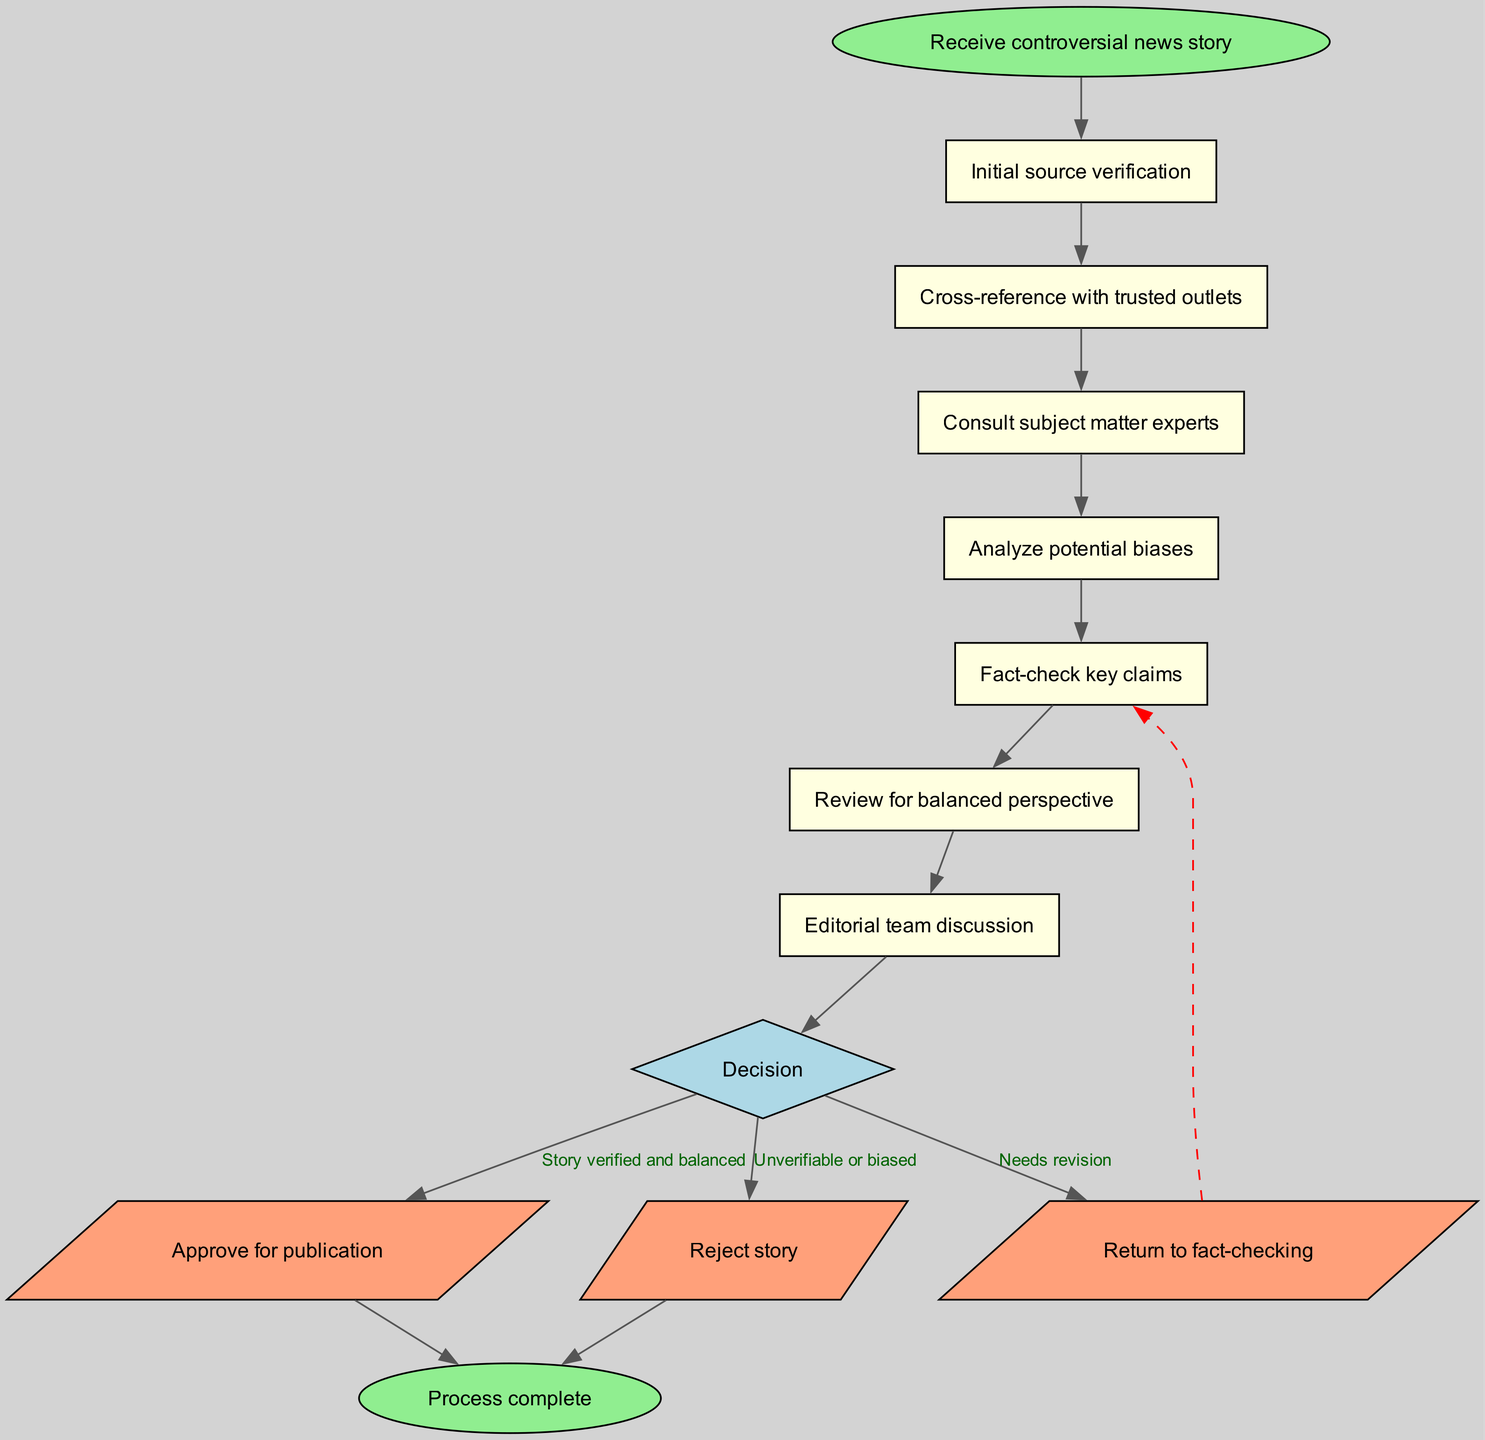What is the first step in the editorial process? The diagram starts with "Receive controversial news story" as the first step in the process. This is the initial action that sets off the flow of the editorial process.
Answer: Receive controversial news story How many main steps are there in the flow chart? The diagram lists six main steps before the decision node, including the final review step, which totals seven steps to consider in the flow word.
Answer: Seven What condition leads to the action of "Approve for publication"? According to the diagram, the condition for approving the story is "Story verified and balanced." This indicates that both verification and balance have passed their assessment in order to publish.
Answer: Story verified and balanced What happens if the story is "Unverifiable or biased"? In the flow chart, if the condition "Unverifiable or biased" is met during the decision phase, the action taken is to "Reject story." This is a clear outcome for issues found with the story's credibility or fairness.
Answer: Reject story After "Review for balanced perspective," what is the next step? The diagram indicates that after "Review for balanced perspective," the next step is an "Editorial team discussion." This implies that discussions occur before a final decision is made.
Answer: Editorial team discussion If the story needs revision, what is the next action taken? The flow chart specifies that if the outcome indicates "Needs revision," the action taken is to "Return to fact-checking." This shows that the process loops back to an earlier stage to address identified issues.
Answer: Return to fact-checking What are the two possible outcomes from the "Editorial team discussion"? The diagram outlines that from the "Editorial team discussion," there are three possible decisions: "Approve for publication," "Needs revision," and "Unverifiable or biased." This shows the variety of potential outcomes post-discussion.
Answer: Three What shape represents the decision node in the flow chart? The decision node is represented by a diamond shape in the diagram. This standard shape indicates a point in the process where a choice must be made based on conditions evaluated by the editorial team.
Answer: Diamond shape 